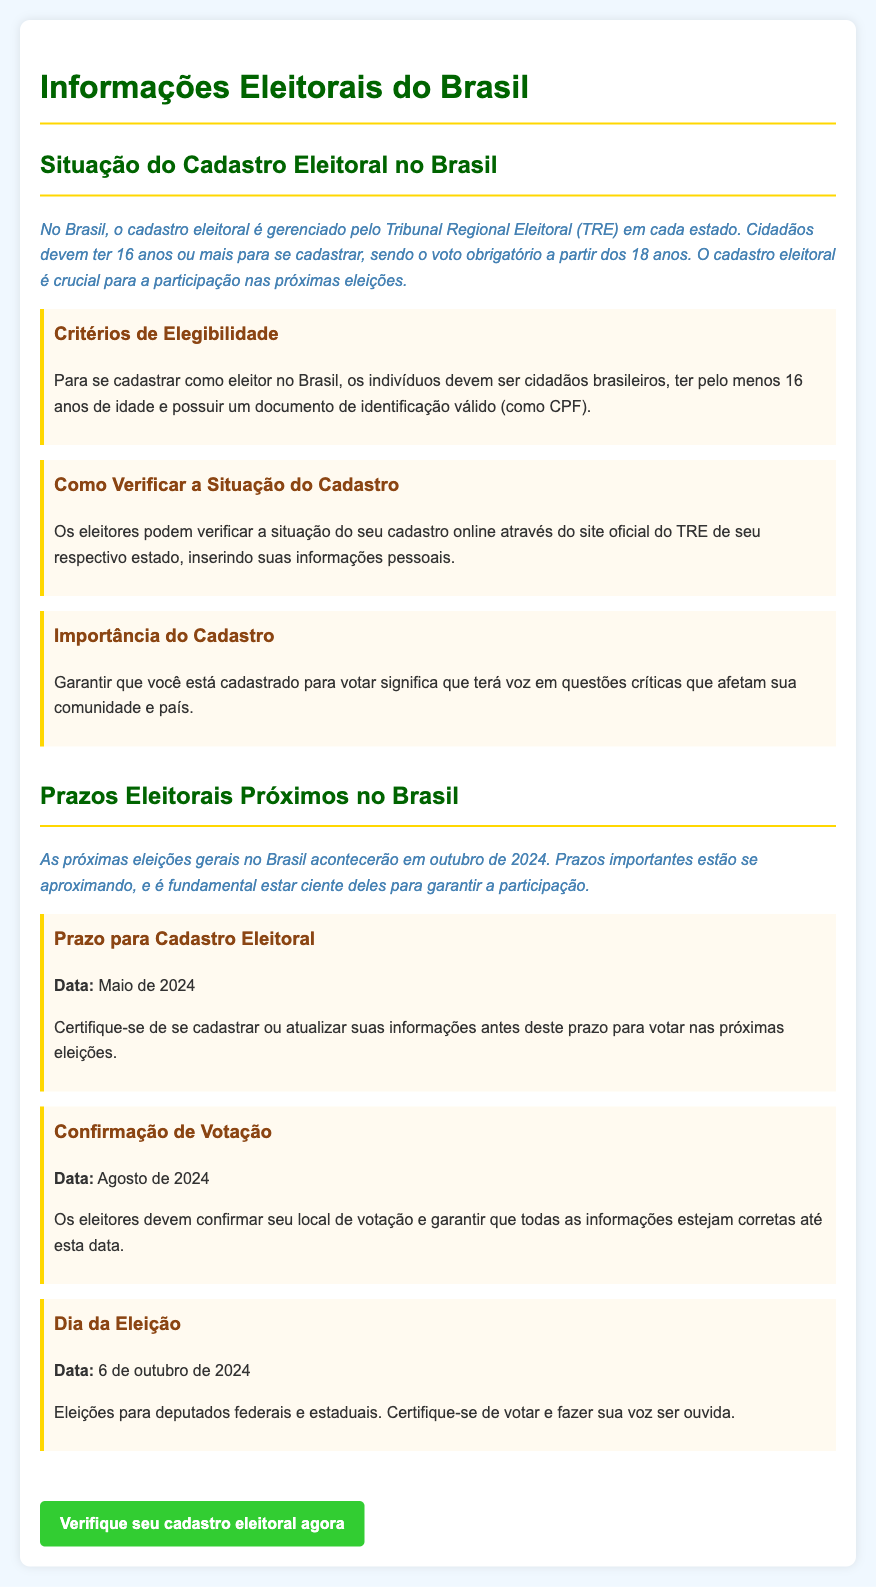Qual é a idade mínima para se cadastrar como eleitor? A idade mínima para se cadastrar como eleitor no Brasil é mencionada como 16 anos.
Answer: 16 anos Qual é a data limite para o cadastro eleitoral? O prazo para o cadastro eleitoral é definido para Maio de 2024, conforme indicado no documento.
Answer: Maio de 2024 O que os cidadãos precisam para se cadastrar? O documento especifica que os indivíduos devem possuir um documento de identificação válido, como o CPF, para se cadastrar.
Answer: Documento de identificação válido (como CPF) Em que data ocorrem as próximas eleições? O dia da eleição é marcado para 6 de outubro de 2024, conforme listado no documento.
Answer: 6 de outubro de 2024 Qual é a importância do cadastro eleitoral? O documento destaca que o cadastro é crucial para que os cidadãos tenham voz em questões que afetam a comunidade e o país.
Answer: Garantir voz em questões críticas Quando os eleitores devem confirmar seu local de votação? A confirmação do local de votação deve ser feita até Agosto de 2024, segundo as informações do documento.
Answer: Agosto de 2024 Qual é o papel do Tribunal Regional Eleitoral? O TRE é responsável pelo gerenciamento do cadastro eleitoral em cada estado, conforme mencionado no documento.
Answer: Gerenciamento do cadastro eleitoral Qual é a consequência de não estar cadastrado? O documento implica que não estar cadastrado significa não poder votar nas próximas eleições.
Answer: Não poder votar Onde os eleitores podem verificar a situação do cadastro? Eleitores podem verificar a situação do seu cadastro no site oficial do TRE de seu estado.
Answer: Site oficial do TRE 